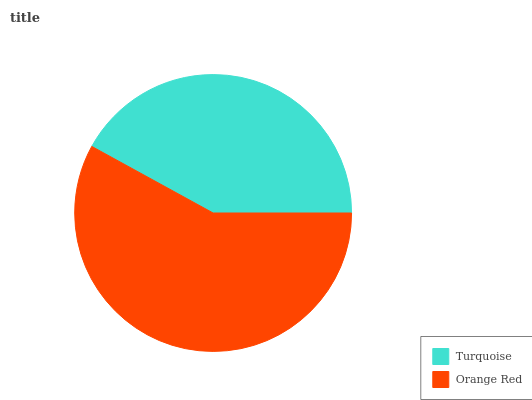Is Turquoise the minimum?
Answer yes or no. Yes. Is Orange Red the maximum?
Answer yes or no. Yes. Is Orange Red the minimum?
Answer yes or no. No. Is Orange Red greater than Turquoise?
Answer yes or no. Yes. Is Turquoise less than Orange Red?
Answer yes or no. Yes. Is Turquoise greater than Orange Red?
Answer yes or no. No. Is Orange Red less than Turquoise?
Answer yes or no. No. Is Orange Red the high median?
Answer yes or no. Yes. Is Turquoise the low median?
Answer yes or no. Yes. Is Turquoise the high median?
Answer yes or no. No. Is Orange Red the low median?
Answer yes or no. No. 